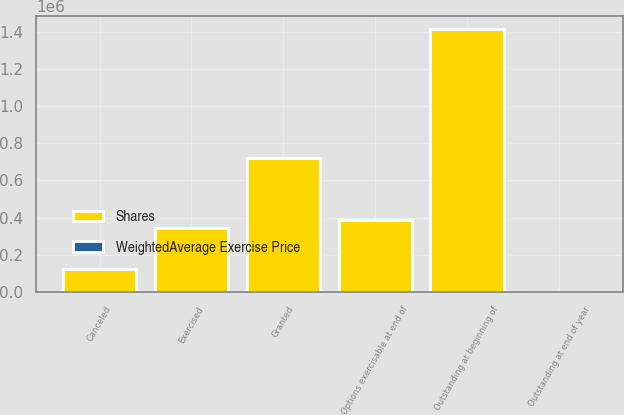<chart> <loc_0><loc_0><loc_500><loc_500><stacked_bar_chart><ecel><fcel>Outstanding at beginning of<fcel>Granted<fcel>Exercised<fcel>Canceled<fcel>Outstanding at end of year<fcel>Options exercisable at end of<nl><fcel>Shares<fcel>1.41338e+06<fcel>718750<fcel>342001<fcel>124739<fcel>49.02<fcel>385201<nl><fcel>WeightedAverage Exercise Price<fcel>38.38<fcel>49.02<fcel>32.09<fcel>48.45<fcel>43.51<fcel>34.87<nl></chart> 